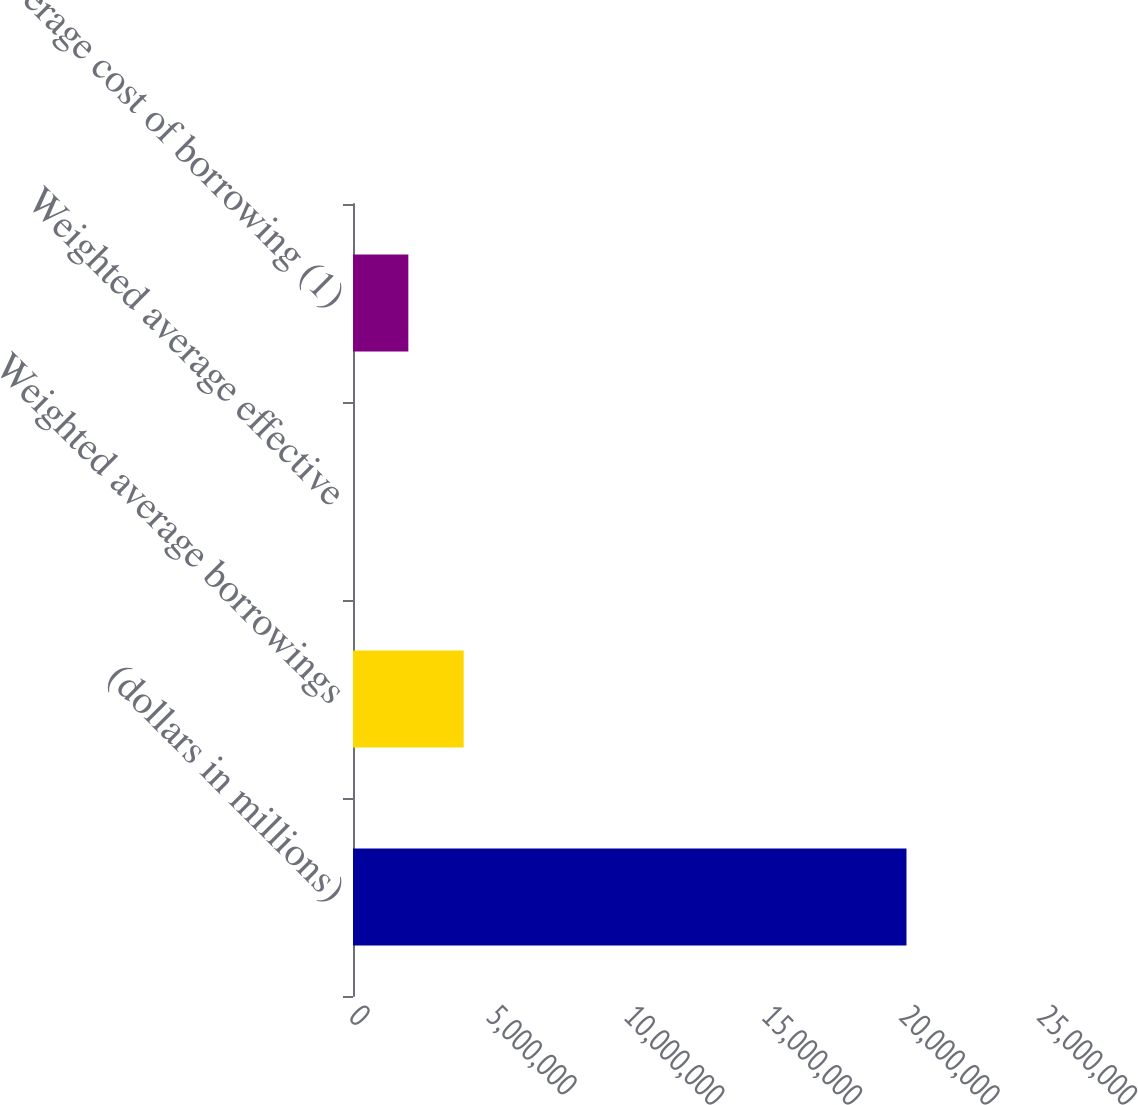Convert chart to OTSL. <chart><loc_0><loc_0><loc_500><loc_500><bar_chart><fcel>(dollars in millions)<fcel>Weighted average borrowings<fcel>Weighted average effective<fcel>Average cost of borrowing (1)<nl><fcel>2.0112e+07<fcel>4.0224e+06<fcel>0.22<fcel>2.0112e+06<nl></chart> 